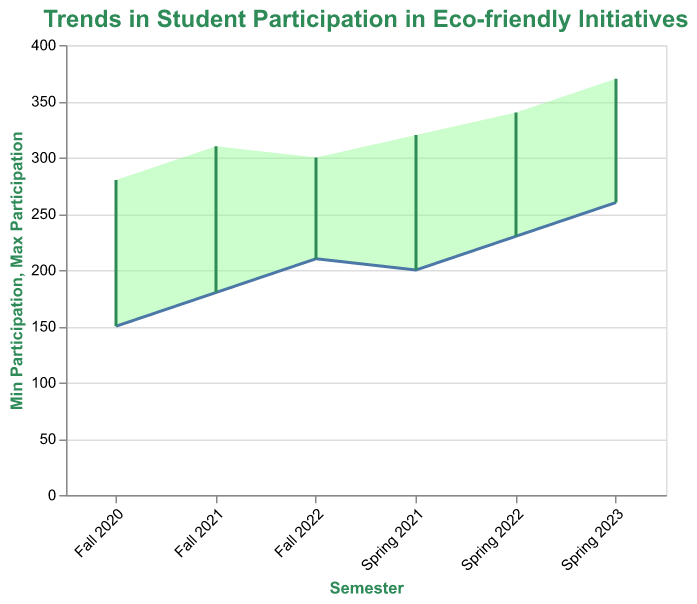What is the title of the chart? The title of the chart is at the top and describes the main theme of the visualization.
Answer: Trends in Student Participation in Eco-friendly Initiatives How many semesters are represented in the chart? By counting the distinct marks on the X-axis, we can identify the number of semesters.
Answer: Six What is the range of participation in Fall 2020? The range is marked by the minimum and maximum participation values for Fall 2020 on the Y-axis.
Answer: 150 to 280 Which semester has the highest maximum participation? By comparing the maximum participation values across all semesters, we can determine which has the highest.
Answer: Spring 2023 What is the average minimum participation across all semesters? To find the average, sum all the minimum participation values and divide by the number of semesters (150 + 200 + 180 + 230 + 210 + 260) / 6.
Answer: 205 Which semester shows a decrease in maximum participation compared to the previous semester? Comparing the maximum participation values semester by semester, we can identify decreases.
Answer: Fall 2022 Is there a semester where both the minimum and maximum participation increased compared to the previous semester? Check each semester's values against the previous one to confirm increases for both minimum and maximum participation.
Answer: Spring 2021 What is the difference between the minimum and maximum participation in Spring 2022? Subtract the minimum participation from the maximum participation for Spring 2022 (340 - 230).
Answer: 110 Which semester has the narrowest range of participation? Calculate the range (difference between maximum and minimum) for each semester and find the smallest value.
Answer: Fall 2022 How has student participation trended over time from Fall 2020 to Spring 2023? Analyze the overall pattern of both minimum and maximum participation values across the semesters.
Answer: Increasing 